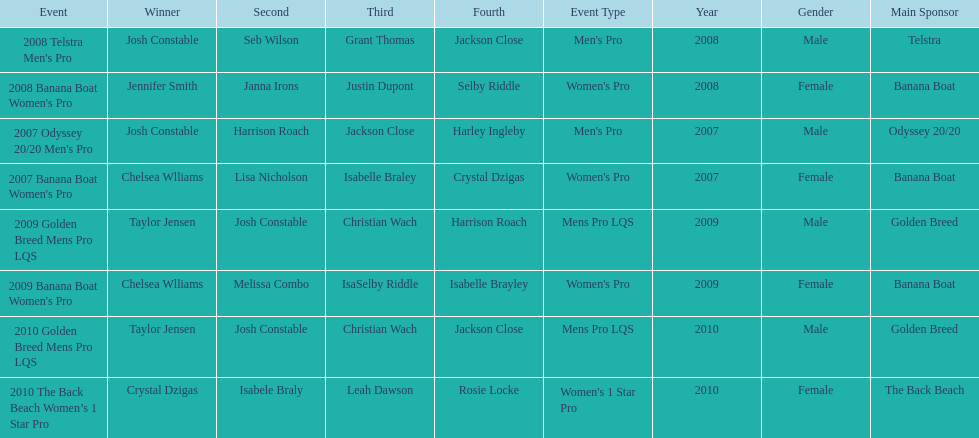What is the total number of times chelsea williams was the winner between 2007 and 2010? 2. 